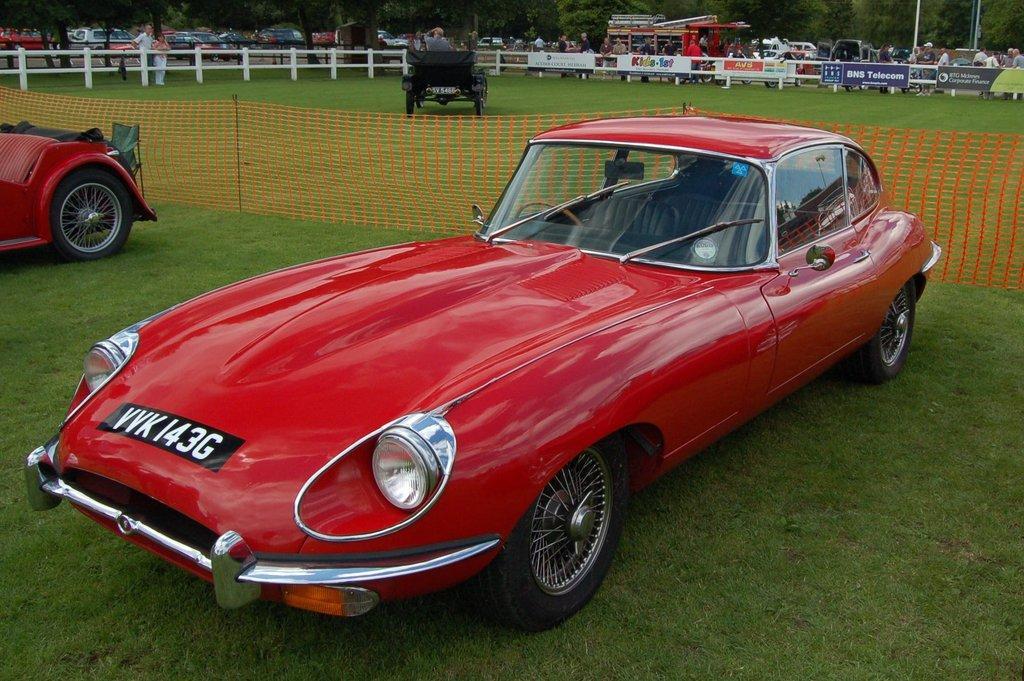How would you summarize this image in a sentence or two? This picture is clicked outside. In the foreground we can see the two red color cars parked on the ground and there is a net and we can see the ground is covered with the green grass. In the background we can see the trees, group of persons, group of vehicles, white color fence and many other objects. 